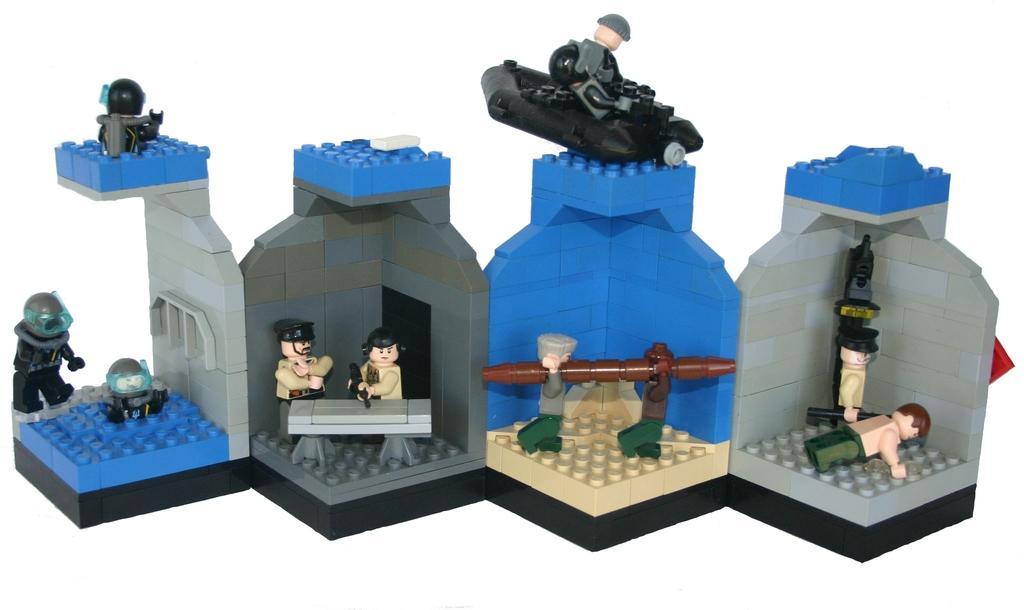Can you describe this image briefly? In this image we can see there are lego boards and toys. 